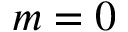Convert formula to latex. <formula><loc_0><loc_0><loc_500><loc_500>m = 0</formula> 